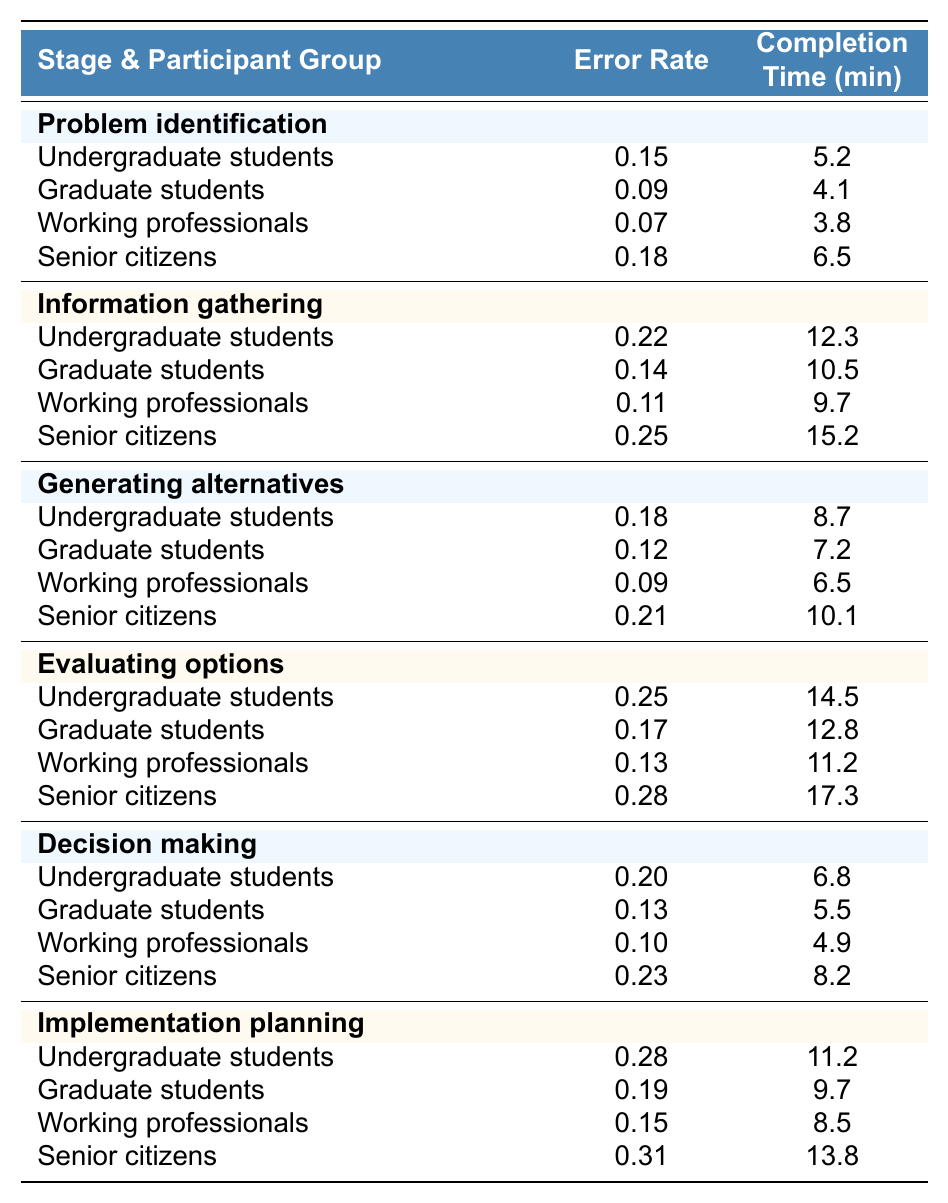What is the error rate for undergraduate students in the stage of decision making? According to the table, the error rate for undergraduate students during the decision-making stage is listed as 0.20.
Answer: 0.20 What is the completion time for senior citizens in the information gathering stage? In the table, the completion time for senior citizens in the information gathering stage is recorded as 15.2 minutes.
Answer: 15.2 minutes Who has the highest error rate in the stage of evaluating options? By examining the table, senior citizens have the highest error rate of 0.28 in the evaluating options stage compared to other participant groups.
Answer: Senior citizens What is the average completion time for working professionals across all stages? The completion times for working professionals in all stages are: 3.8 (problem identification) + 9.7 (information gathering) + 6.5 (generating alternatives) + 11.2 (evaluating options) + 4.9 (decision making) + 8.5 (implementation planning) = 44.6 minutes. There are 6 stages, so the average is 44.6/6 = 7.433, rounded to three decimal places.
Answer: 7.433 minutes Is the error rate for graduate students lower in the stage of problem identification compared to that in the stage of generating alternatives? The error rate for graduate students in problem identification is 0.09, and in generating alternatives, it is 0.12. Since 0.09 is less than 0.12, the statement is true.
Answer: Yes Which participant group has the fastest completion time in the implementation planning stage? In the implementation planning stage, the completion times for each group are as follows: undergraduate students (11.2), graduate students (9.7), working professionals (8.5), and senior citizens (13.8). Working professionals have the fastest time at 8.5 minutes.
Answer: Working professionals What is the difference in error rates between senior citizens and working professionals in the stage of generating alternatives? In the generating alternatives stage, senior citizens have an error rate of 0.21, while working professionals have an error rate of 0.09. The difference is calculated as 0.21 - 0.09 = 0.12.
Answer: 0.12 Who exhibits the highest error rate in the information gathering stage? Evaluating the information gathering stage, senior citizens show the highest error rate of 0.25, as compared to undergraduate (0.22), graduate (0.14), and working professionals (0.11).
Answer: Senior citizens What is the completion time for the stage of evaluating options for graduate students? In the table, the completion time for graduate students in the evaluating options stage is noted as 12.8 minutes.
Answer: 12.8 minutes Compare the average error rate across all stages for undergraduate students to that for senior citizens. Which group has a higher average? For undergraduate students: (0.15 + 0.22 + 0.18 + 0.25 + 0.20 + 0.28) = 1.28, average = 1.28/6 = 0.2133. For senior citizens: (0.18 + 0.25 + 0.21 + 0.28 + 0.23 + 0.31) = 1.56, average = 1.56/6 = 0.26. Senior citizens have a higher average error rate.
Answer: Senior citizens 